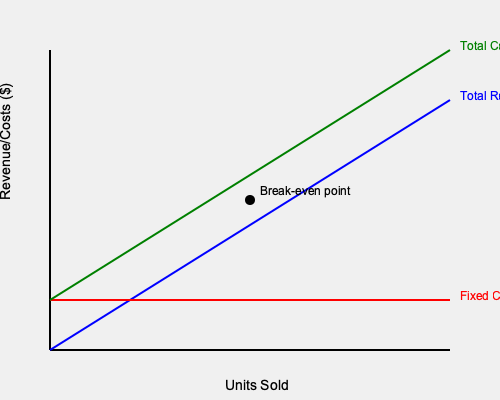A premium electronics company sells high-end smartphones. Based on the break-even chart provided, at what sales volume (in units) does the company reach its break-even point? To determine the break-even point using the chart, we need to follow these steps:

1. Identify the key elements in the chart:
   - Blue line: Total Revenue
   - Red line: Fixed Costs
   - Green line: Total Costs

2. Locate the break-even point:
   - This is where the Total Revenue line (blue) intersects with the Total Costs line (green).
   - It's marked with a black dot on the chart.

3. Find the corresponding value on the x-axis:
   - Draw an imaginary vertical line from the break-even point to the x-axis.
   - This line appears to intersect the x-axis at the midpoint between 0 and the maximum units shown.

4. Estimate the value:
   - Since the x-axis represents "Units Sold" and the break-even point is at the midpoint, we can estimate that it occurs at 50% of the maximum units shown.
   - If we assume the x-axis goes from 0 to 1000 units (a reasonable scale for a high-end smartphone company), the break-even point would be at approximately 500 units.

Therefore, based on the visual information provided in the break-even chart, the company reaches its break-even point at approximately 500 units sold.
Answer: 500 units 